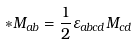<formula> <loc_0><loc_0><loc_500><loc_500>* M _ { a b } = \frac { 1 } { 2 } \varepsilon _ { a b c d } M _ { c d }</formula> 